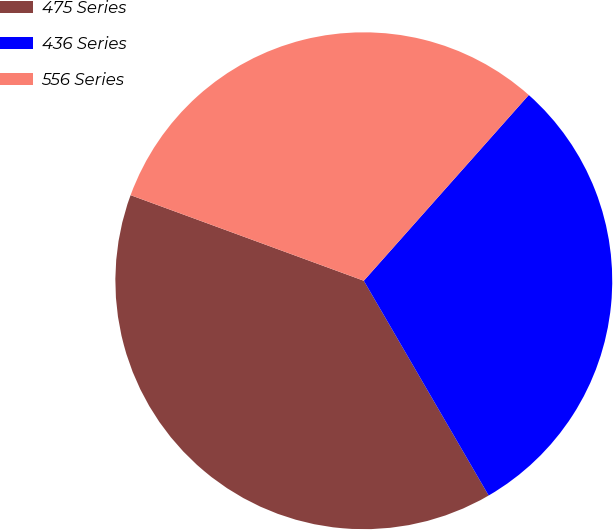Convert chart. <chart><loc_0><loc_0><loc_500><loc_500><pie_chart><fcel>475 Series<fcel>436 Series<fcel>556 Series<nl><fcel>38.98%<fcel>30.06%<fcel>30.96%<nl></chart> 